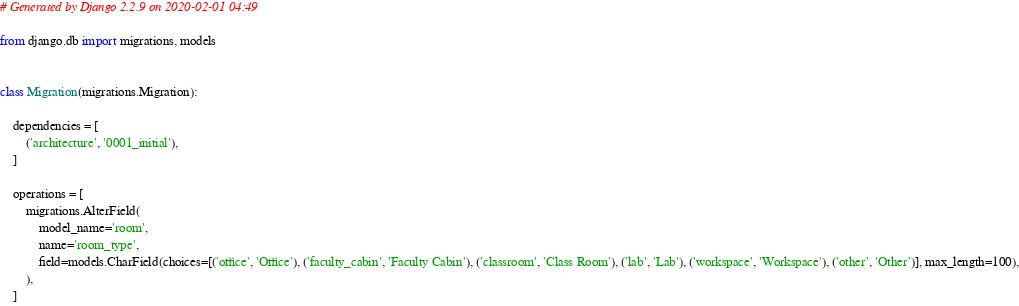Convert code to text. <code><loc_0><loc_0><loc_500><loc_500><_Python_># Generated by Django 2.2.9 on 2020-02-01 04:49

from django.db import migrations, models


class Migration(migrations.Migration):

    dependencies = [
        ('architecture', '0001_initial'),
    ]

    operations = [
        migrations.AlterField(
            model_name='room',
            name='room_type',
            field=models.CharField(choices=[('office', 'Office'), ('faculty_cabin', 'Faculty Cabin'), ('classroom', 'Class Room'), ('lab', 'Lab'), ('workspace', 'Workspace'), ('other', 'Other')], max_length=100),
        ),
    ]
</code> 